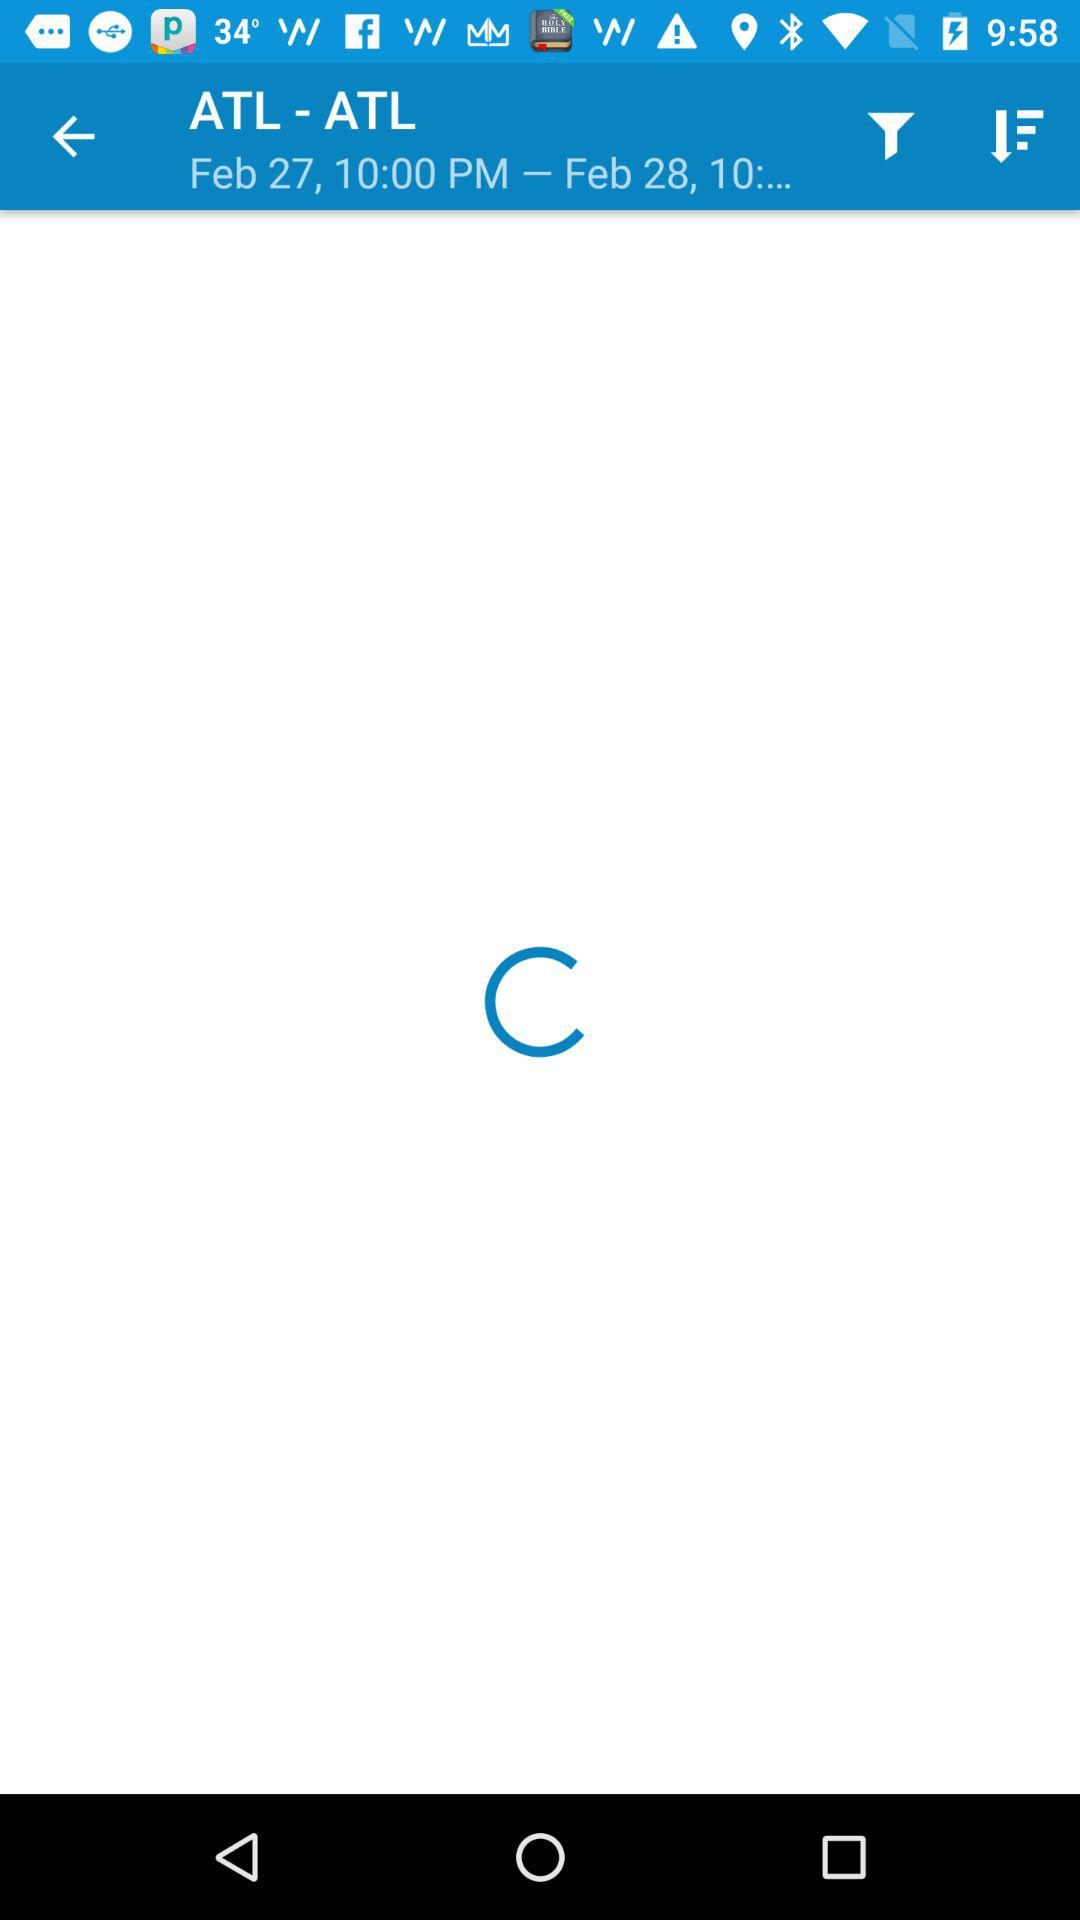What is the date and time for "ATL - ATL"? The date and time is "Feb 27, 10:00 PM – Feb 28, 10:...". 